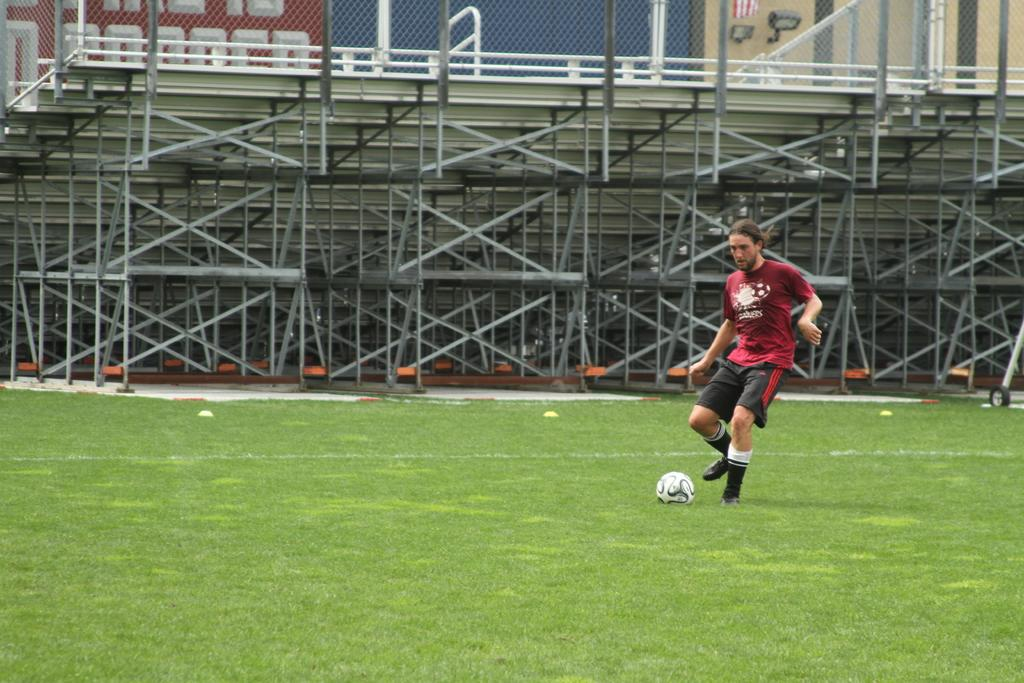What is the main subject of the image? There is a person in the image. What object is also visible in the image? There is a ball in the image. What type of surface is the person and ball on? There is grass on the ground in the image. What structures can be seen in the image? There are rods and a mesh visible in the image. What type of text is present in the image? There is text visible in the image. What other objects can be seen in the image? There are other objects in the image. What can be seen in the background of the image? There are walls visible in the background of the image. What type of club is being used in the image? There is no club present in the image. What boundary is visible in the image? There is no boundary visible in the image. What type of office can be seen in the background of the image? There is no office visible in the image; only walls are present in the background. 